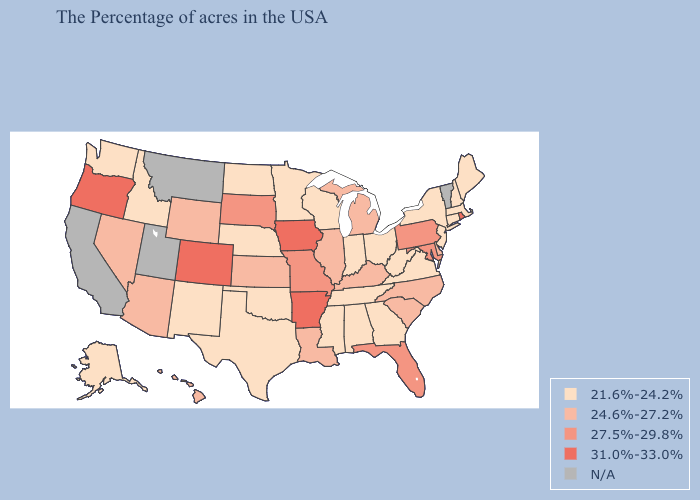Name the states that have a value in the range N/A?
Keep it brief. Vermont, Utah, Montana, California. Does the map have missing data?
Short answer required. Yes. Does Colorado have the lowest value in the USA?
Write a very short answer. No. Does the first symbol in the legend represent the smallest category?
Give a very brief answer. Yes. What is the highest value in states that border North Carolina?
Give a very brief answer. 24.6%-27.2%. What is the value of Alabama?
Be succinct. 21.6%-24.2%. What is the value of Georgia?
Give a very brief answer. 21.6%-24.2%. Does Delaware have the highest value in the South?
Keep it brief. No. Which states hav the highest value in the Northeast?
Quick response, please. Rhode Island. Name the states that have a value in the range 21.6%-24.2%?
Write a very short answer. Maine, Massachusetts, New Hampshire, Connecticut, New York, New Jersey, Virginia, West Virginia, Ohio, Georgia, Indiana, Alabama, Tennessee, Wisconsin, Mississippi, Minnesota, Nebraska, Oklahoma, Texas, North Dakota, New Mexico, Idaho, Washington, Alaska. Name the states that have a value in the range N/A?
Give a very brief answer. Vermont, Utah, Montana, California. What is the lowest value in the West?
Concise answer only. 21.6%-24.2%. Which states have the lowest value in the USA?
Keep it brief. Maine, Massachusetts, New Hampshire, Connecticut, New York, New Jersey, Virginia, West Virginia, Ohio, Georgia, Indiana, Alabama, Tennessee, Wisconsin, Mississippi, Minnesota, Nebraska, Oklahoma, Texas, North Dakota, New Mexico, Idaho, Washington, Alaska. How many symbols are there in the legend?
Write a very short answer. 5. Among the states that border Washington , does Oregon have the highest value?
Keep it brief. Yes. 